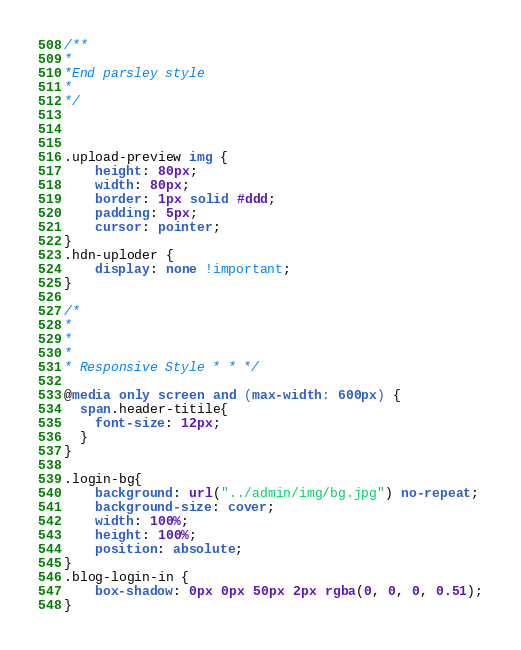Convert code to text. <code><loc_0><loc_0><loc_500><loc_500><_CSS_>/**
*
*End parsley style
*
*/



.upload-preview img {
    height: 80px;
    width: 80px;
    border: 1px solid #ddd;
    padding: 5px;
    cursor: pointer;
}
.hdn-uploder {
    display: none !important;
}

/*
*
*
*
* Responsive Style * * */

@media only screen and (max-width: 600px) {
  span.header-titile{
    font-size: 12px;
  }
}

.login-bg{
    background: url("../admin/img/bg.jpg") no-repeat;
    background-size: cover;
    width: 100%;
    height: 100%;
    position: absolute;
}
.blog-login-in {
    box-shadow: 0px 0px 50px 2px rgba(0, 0, 0, 0.51);
}
</code> 